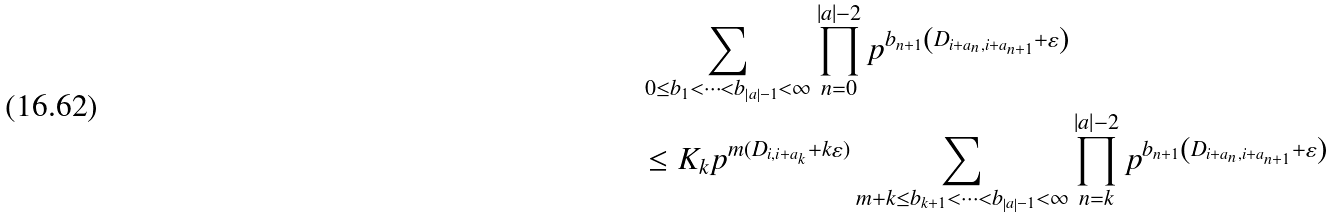Convert formula to latex. <formula><loc_0><loc_0><loc_500><loc_500>& \sum _ { 0 \leq b _ { 1 } < \dots < b _ { \left | a \right | - 1 } < \infty } \prod _ { n = 0 } ^ { \left | a \right | - 2 } p ^ { b _ { n + 1 } \left ( D _ { i + a _ { n } , i + a _ { n + 1 } } + \varepsilon \right ) } \\ & \leq K _ { k } p ^ { m ( D _ { i , i + a _ { k } } + k \varepsilon ) } \sum _ { m + k \leq b _ { k + 1 } < \dots < b _ { \left | a \right | - 1 } < \infty } \prod _ { n = k } ^ { \left | a \right | - 2 } p ^ { b _ { n + 1 } \left ( D _ { i + a _ { n } , i + a _ { n + 1 } } + \varepsilon \right ) }</formula> 